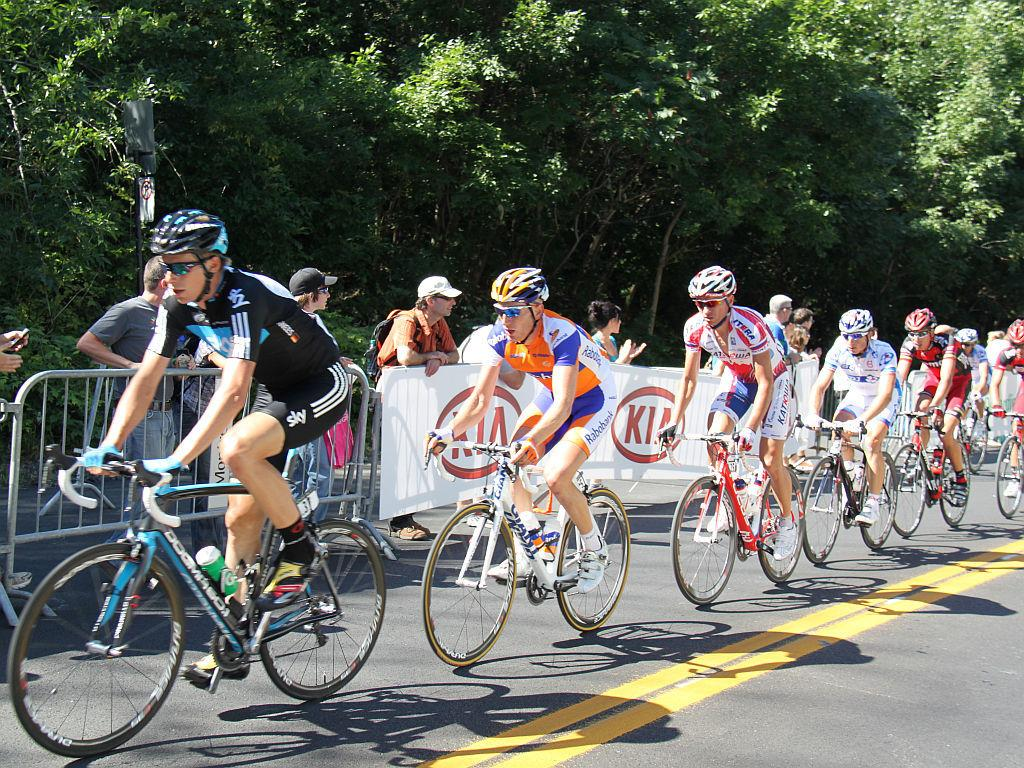How many people are in the image? There is a group of people in the image, but the exact number is not specified. What are some people doing in the image? Some people are riding bicycles in the image. What safety precaution are the bicycle riders taking? The people riding bicycles are wearing helmets. What can be seen in the background of the image? There are trees in the image. What are some people wearing on their heads in the image? Some people in the image are wearing caps. What type of chalk is being used to draw on the field in the image? There is no chalk or field present in the image. How many breaths can be heard from the people in the image? The image is static, so it does not capture any sounds, including breaths. 